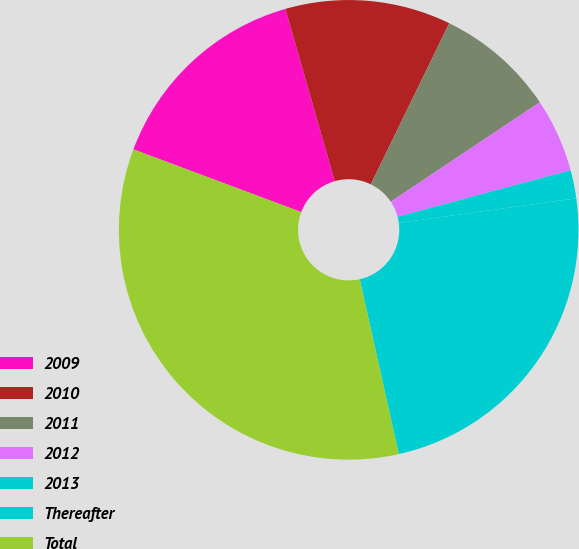Convert chart. <chart><loc_0><loc_0><loc_500><loc_500><pie_chart><fcel>2009<fcel>2010<fcel>2011<fcel>2012<fcel>2013<fcel>Thereafter<fcel>Total<nl><fcel>14.87%<fcel>11.65%<fcel>8.42%<fcel>5.2%<fcel>1.98%<fcel>23.69%<fcel>34.19%<nl></chart> 